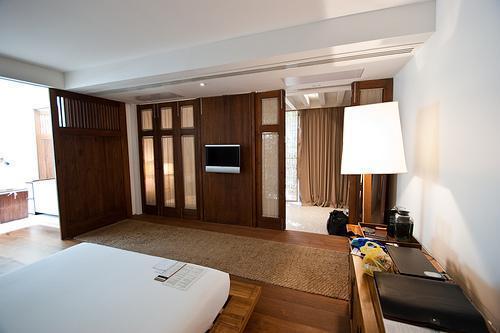How many beds in the room?
Give a very brief answer. 1. How many kites are in the sky?
Give a very brief answer. 0. 